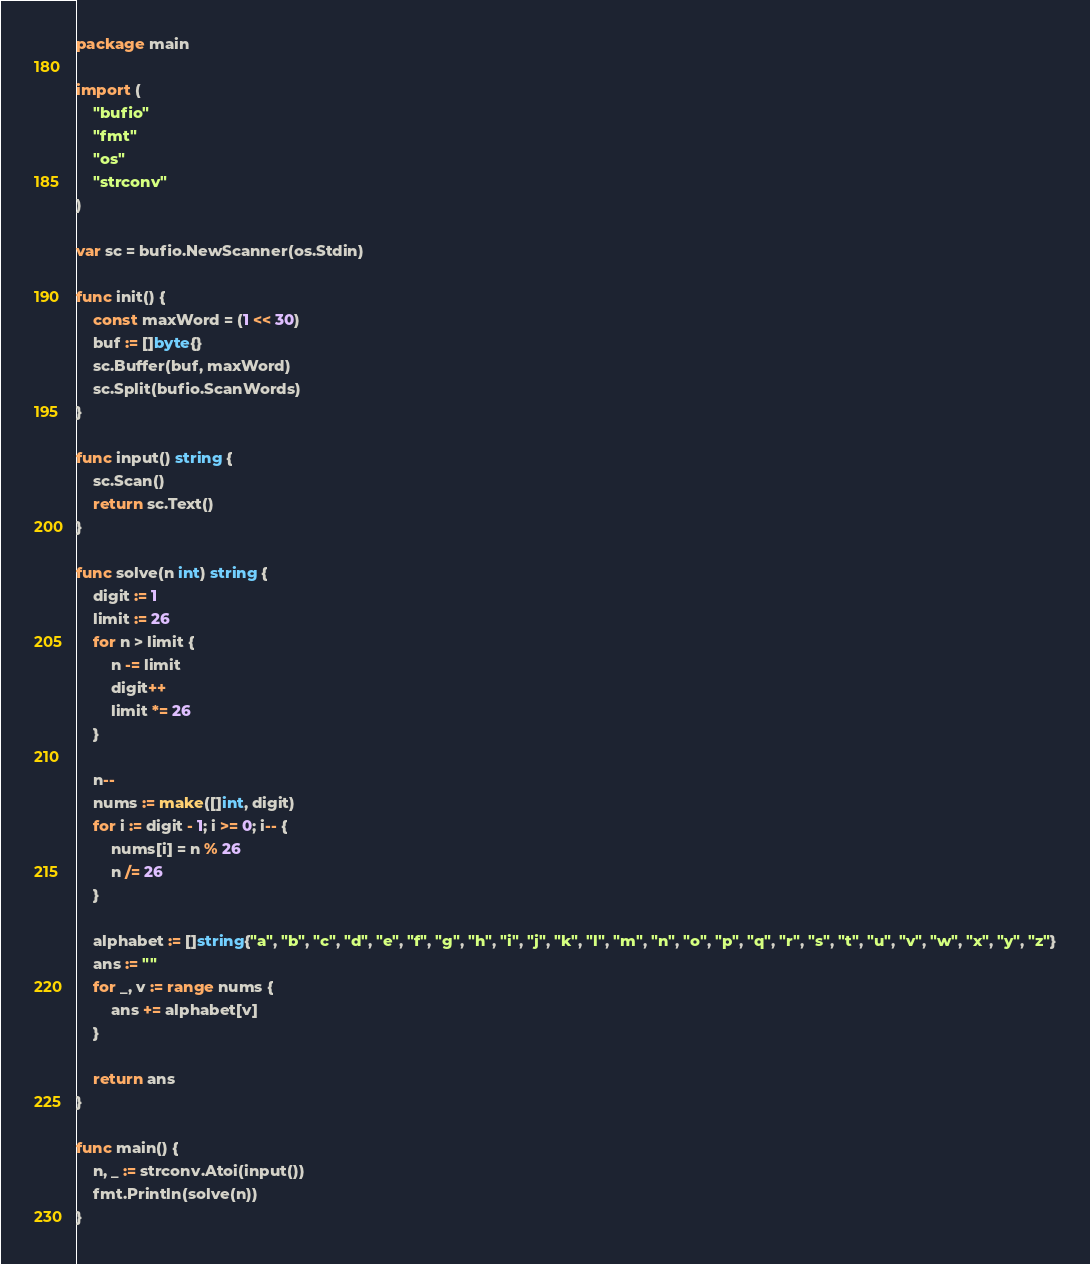Convert code to text. <code><loc_0><loc_0><loc_500><loc_500><_Go_>package main

import (
	"bufio"
	"fmt"
	"os"
	"strconv"
)

var sc = bufio.NewScanner(os.Stdin)

func init() {
	const maxWord = (1 << 30)
	buf := []byte{}
	sc.Buffer(buf, maxWord)
	sc.Split(bufio.ScanWords)
}

func input() string {
	sc.Scan()
	return sc.Text()
}

func solve(n int) string {
	digit := 1
	limit := 26
	for n > limit {
		n -= limit
		digit++
		limit *= 26
	}

	n--
	nums := make([]int, digit)
	for i := digit - 1; i >= 0; i-- {
		nums[i] = n % 26
		n /= 26
	}

	alphabet := []string{"a", "b", "c", "d", "e", "f", "g", "h", "i", "j", "k", "l", "m", "n", "o", "p", "q", "r", "s", "t", "u", "v", "w", "x", "y", "z"}
	ans := ""
	for _, v := range nums {
		ans += alphabet[v]
	}

	return ans
}

func main() {
	n, _ := strconv.Atoi(input())
	fmt.Println(solve(n))
}
</code> 